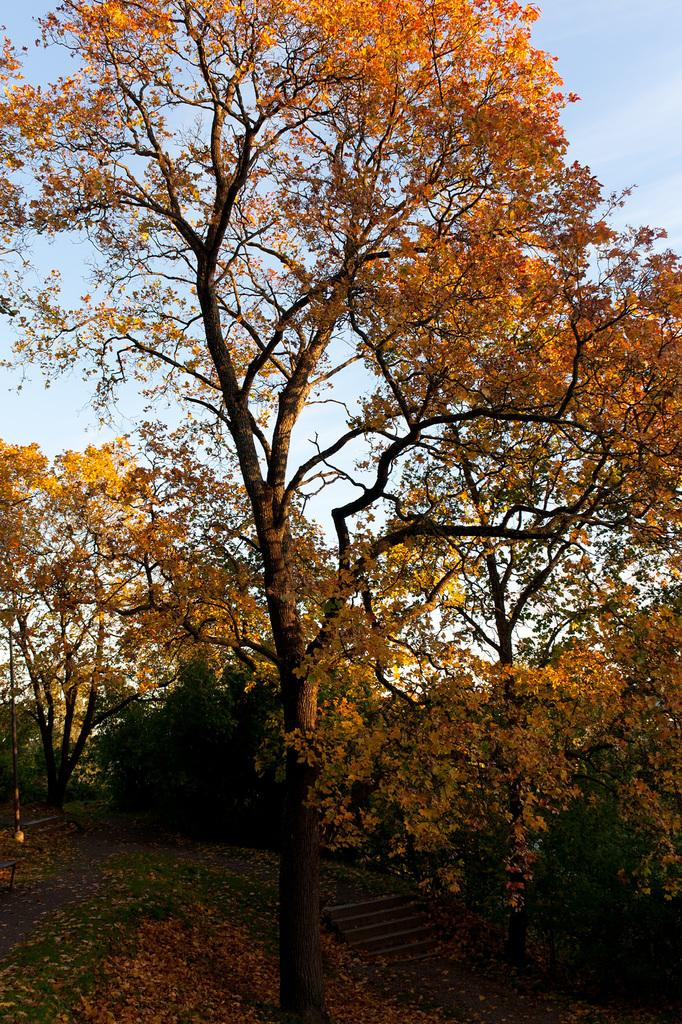What type of vegetation can be seen in the image? There are trees in the image. What architectural feature is present in the image? There are stairs in the image. What type of ground surface is visible in the image? There is grass in the image. What pathway is available for walking in the image? There is a walkway in the image. What can be seen in the background of the image? In the background, there are trees and the sky is visible. What type of bait is used to catch fish in the image? There is no fishing or bait present in the image. What is the tendency of the trees to lean in the image? The trees in the image are not shown leaning, so it is not possible to determine their tendency. 